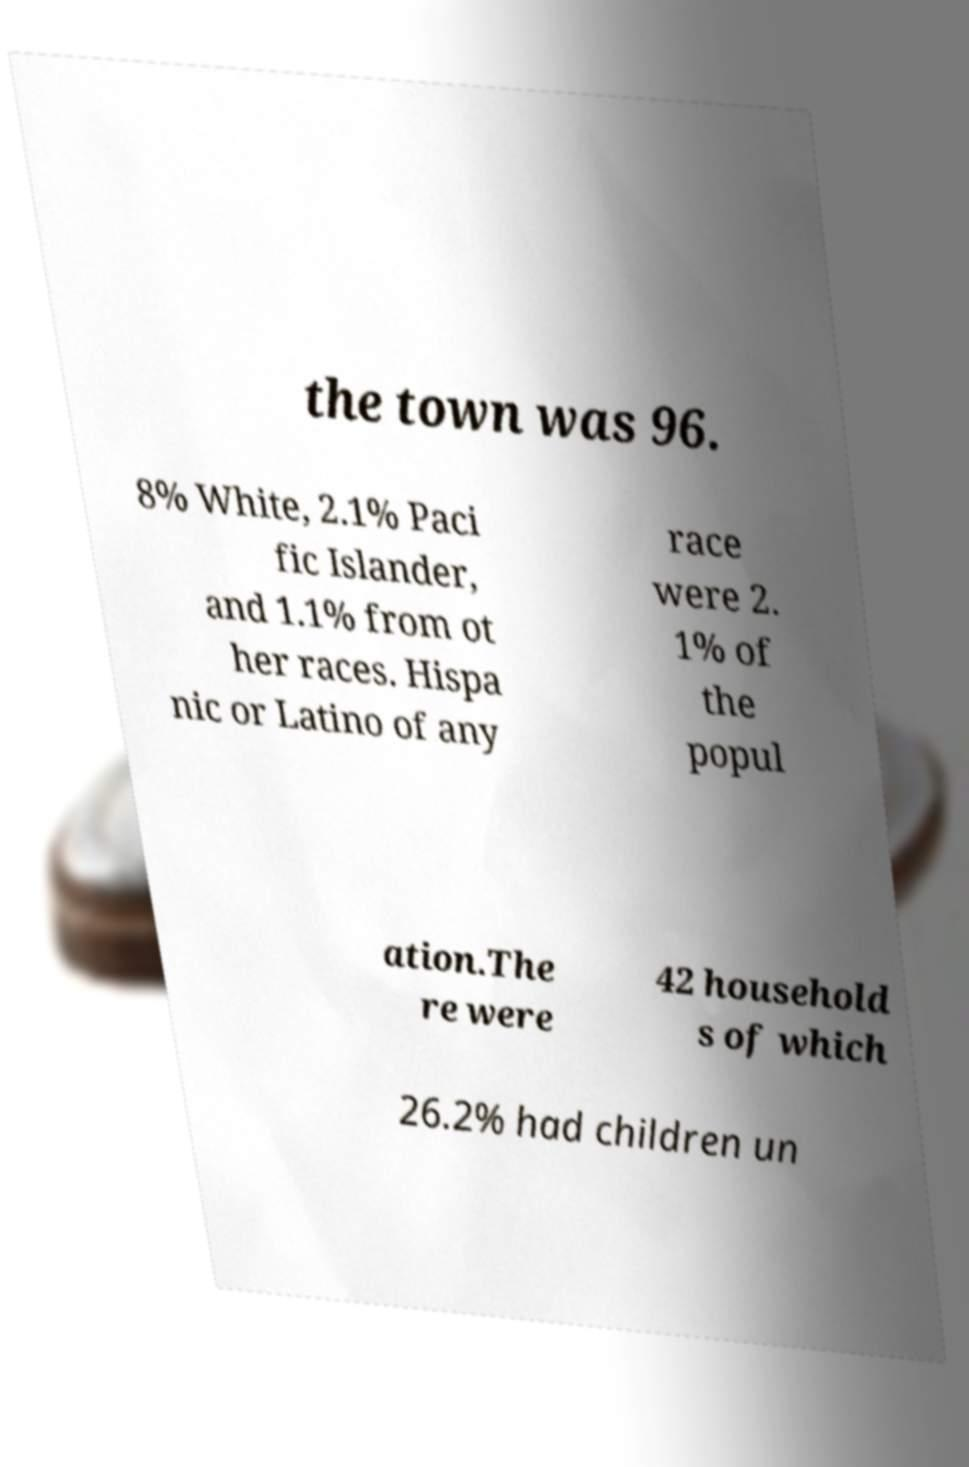Could you extract and type out the text from this image? the town was 96. 8% White, 2.1% Paci fic Islander, and 1.1% from ot her races. Hispa nic or Latino of any race were 2. 1% of the popul ation.The re were 42 household s of which 26.2% had children un 